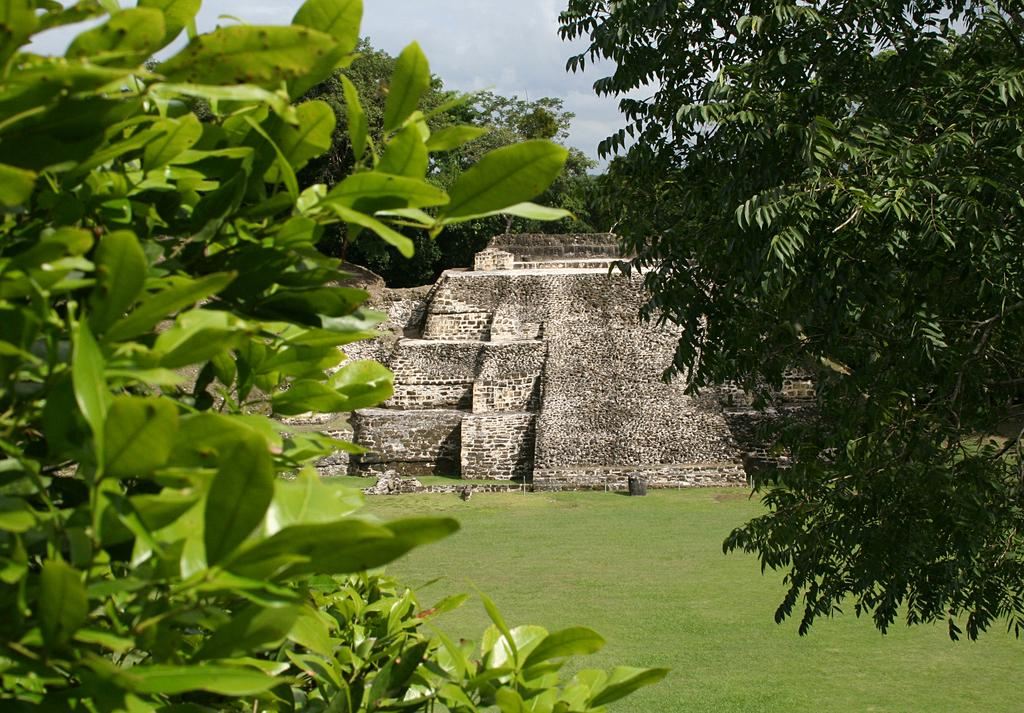What is the main structure in the center of the image? There is a fort in the center of the image. What can be seen in the background of the image? There are trees in the background of the image. What type of surface is visible at the bottom of the image? There is ground visible at the bottom of the image. What type of appliance can be seen in the image? There is no appliance present in the image. What is the name of the son of the person who built the fort? The provided facts do not mention any people or their family members, so it is impossible to answer this question. 